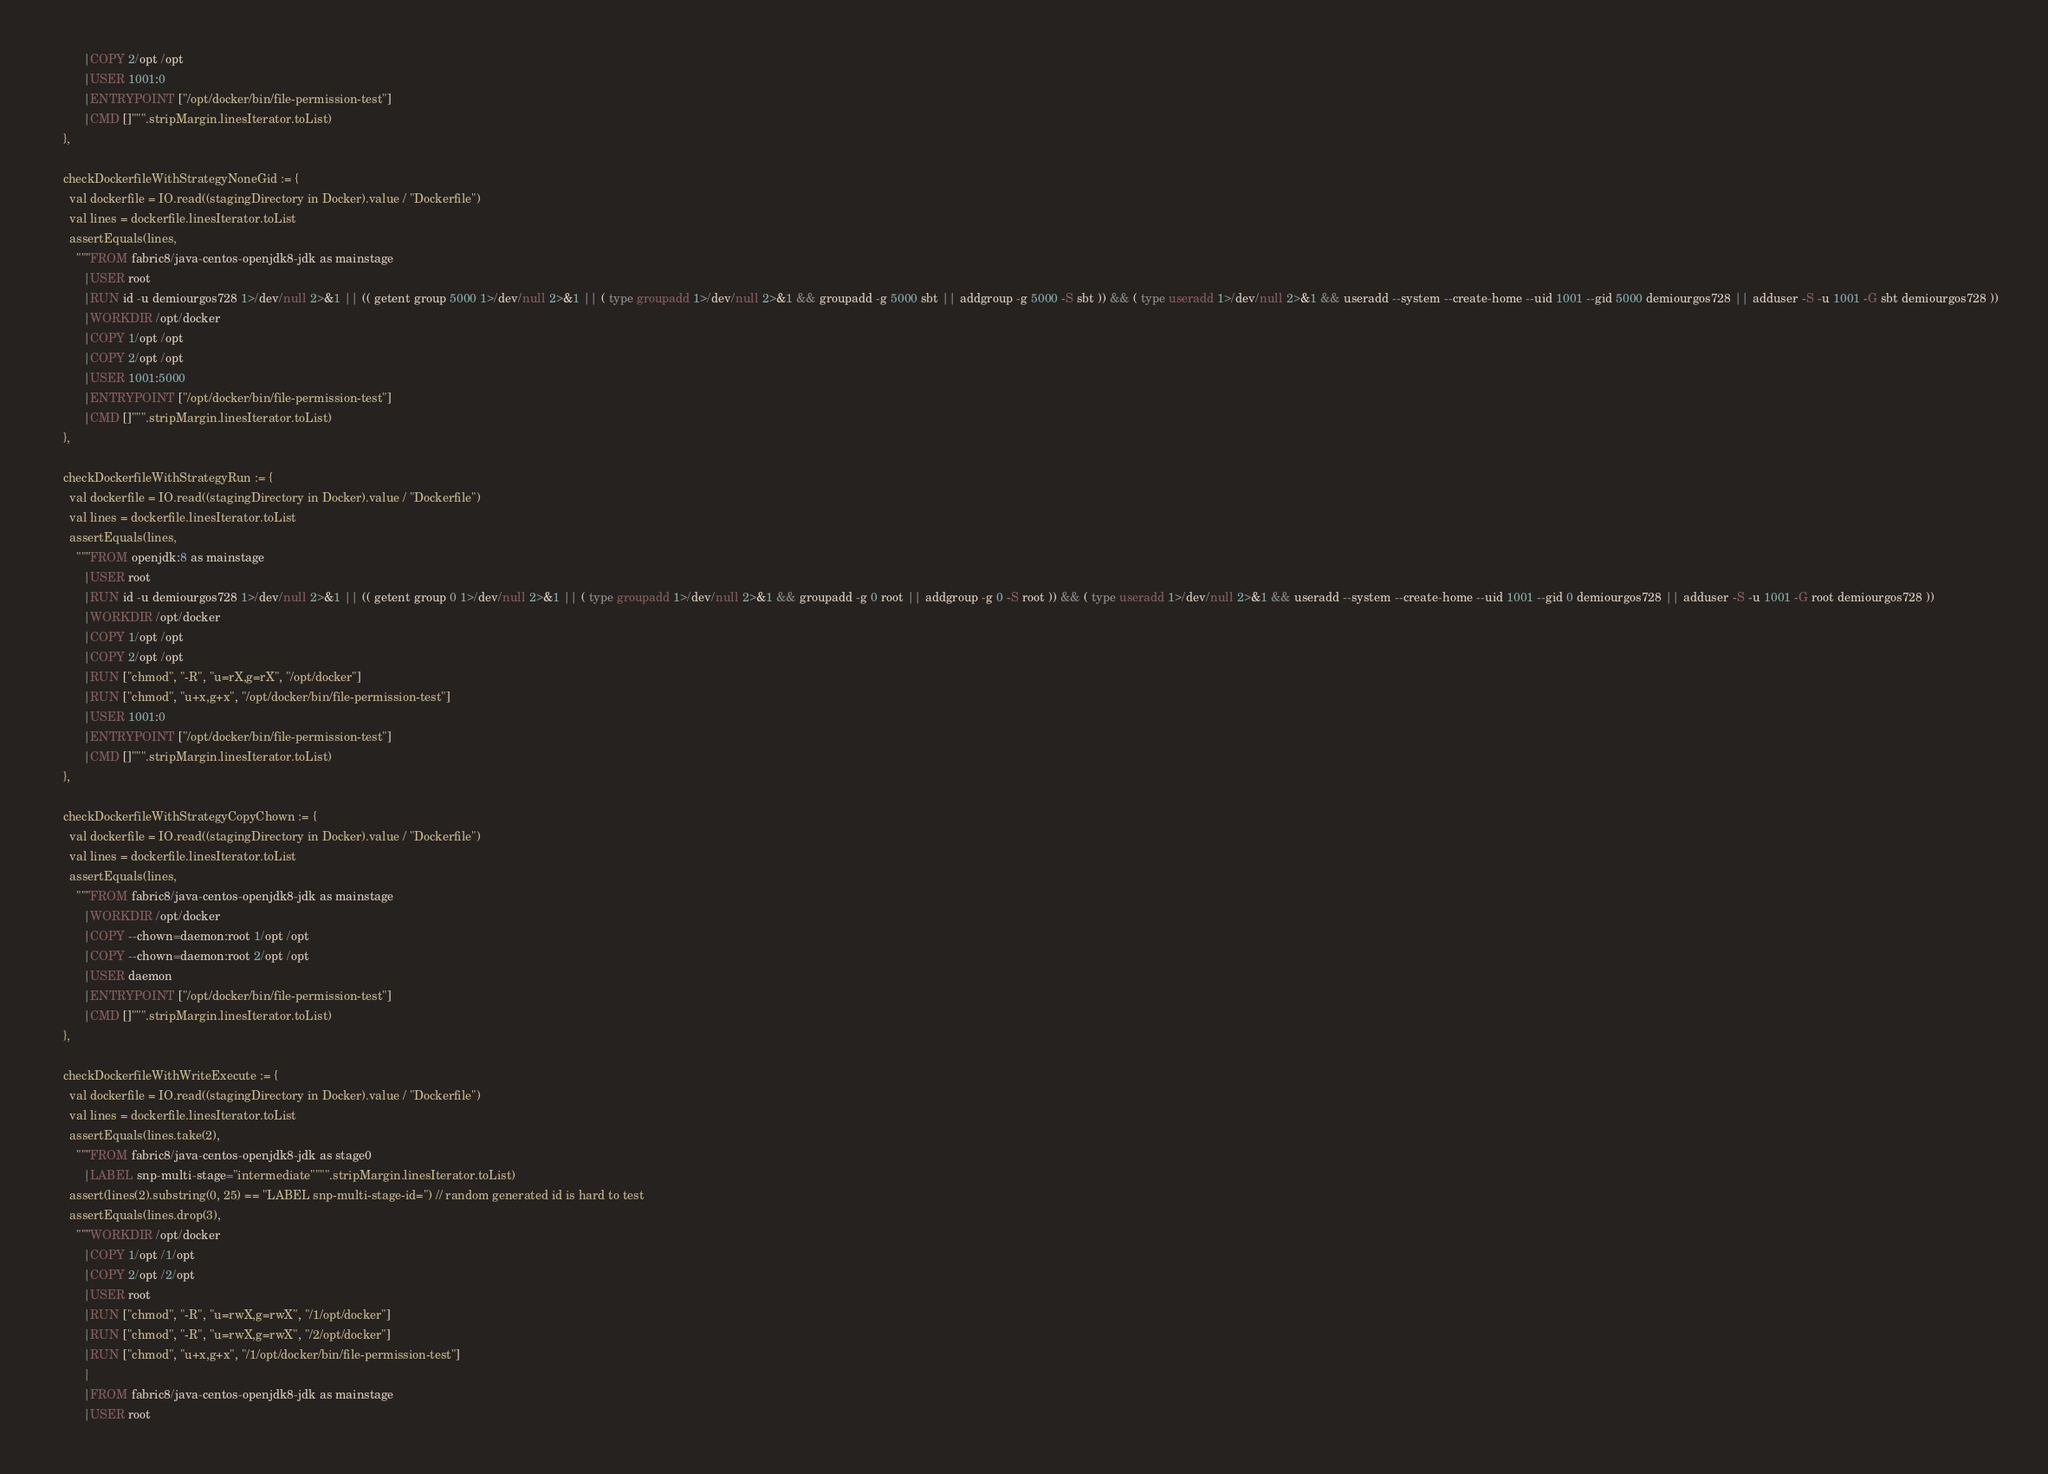Convert code to text. <code><loc_0><loc_0><loc_500><loc_500><_Scala_>          |COPY 2/opt /opt
          |USER 1001:0
          |ENTRYPOINT ["/opt/docker/bin/file-permission-test"]
          |CMD []""".stripMargin.linesIterator.toList)
    },

    checkDockerfileWithStrategyNoneGid := {
      val dockerfile = IO.read((stagingDirectory in Docker).value / "Dockerfile")
      val lines = dockerfile.linesIterator.toList
      assertEquals(lines,
        """FROM fabric8/java-centos-openjdk8-jdk as mainstage
          |USER root
          |RUN id -u demiourgos728 1>/dev/null 2>&1 || (( getent group 5000 1>/dev/null 2>&1 || ( type groupadd 1>/dev/null 2>&1 && groupadd -g 5000 sbt || addgroup -g 5000 -S sbt )) && ( type useradd 1>/dev/null 2>&1 && useradd --system --create-home --uid 1001 --gid 5000 demiourgos728 || adduser -S -u 1001 -G sbt demiourgos728 ))
          |WORKDIR /opt/docker
          |COPY 1/opt /opt
          |COPY 2/opt /opt
          |USER 1001:5000
          |ENTRYPOINT ["/opt/docker/bin/file-permission-test"]
          |CMD []""".stripMargin.linesIterator.toList)
    },

    checkDockerfileWithStrategyRun := {
      val dockerfile = IO.read((stagingDirectory in Docker).value / "Dockerfile")
      val lines = dockerfile.linesIterator.toList
      assertEquals(lines,
        """FROM openjdk:8 as mainstage
          |USER root
          |RUN id -u demiourgos728 1>/dev/null 2>&1 || (( getent group 0 1>/dev/null 2>&1 || ( type groupadd 1>/dev/null 2>&1 && groupadd -g 0 root || addgroup -g 0 -S root )) && ( type useradd 1>/dev/null 2>&1 && useradd --system --create-home --uid 1001 --gid 0 demiourgos728 || adduser -S -u 1001 -G root demiourgos728 ))
          |WORKDIR /opt/docker
          |COPY 1/opt /opt
          |COPY 2/opt /opt
          |RUN ["chmod", "-R", "u=rX,g=rX", "/opt/docker"]
          |RUN ["chmod", "u+x,g+x", "/opt/docker/bin/file-permission-test"]
          |USER 1001:0
          |ENTRYPOINT ["/opt/docker/bin/file-permission-test"]
          |CMD []""".stripMargin.linesIterator.toList)
    },

    checkDockerfileWithStrategyCopyChown := {
      val dockerfile = IO.read((stagingDirectory in Docker).value / "Dockerfile")
      val lines = dockerfile.linesIterator.toList
      assertEquals(lines,
        """FROM fabric8/java-centos-openjdk8-jdk as mainstage
          |WORKDIR /opt/docker
          |COPY --chown=daemon:root 1/opt /opt
          |COPY --chown=daemon:root 2/opt /opt
          |USER daemon
          |ENTRYPOINT ["/opt/docker/bin/file-permission-test"]
          |CMD []""".stripMargin.linesIterator.toList)
    },

    checkDockerfileWithWriteExecute := {
      val dockerfile = IO.read((stagingDirectory in Docker).value / "Dockerfile")
      val lines = dockerfile.linesIterator.toList
      assertEquals(lines.take(2),
        """FROM fabric8/java-centos-openjdk8-jdk as stage0
          |LABEL snp-multi-stage="intermediate"""".stripMargin.linesIterator.toList)
      assert(lines(2).substring(0, 25) == "LABEL snp-multi-stage-id=") // random generated id is hard to test
      assertEquals(lines.drop(3),
        """WORKDIR /opt/docker
          |COPY 1/opt /1/opt
          |COPY 2/opt /2/opt
          |USER root
          |RUN ["chmod", "-R", "u=rwX,g=rwX", "/1/opt/docker"]
          |RUN ["chmod", "-R", "u=rwX,g=rwX", "/2/opt/docker"]
          |RUN ["chmod", "u+x,g+x", "/1/opt/docker/bin/file-permission-test"]
          |
          |FROM fabric8/java-centos-openjdk8-jdk as mainstage
          |USER root</code> 